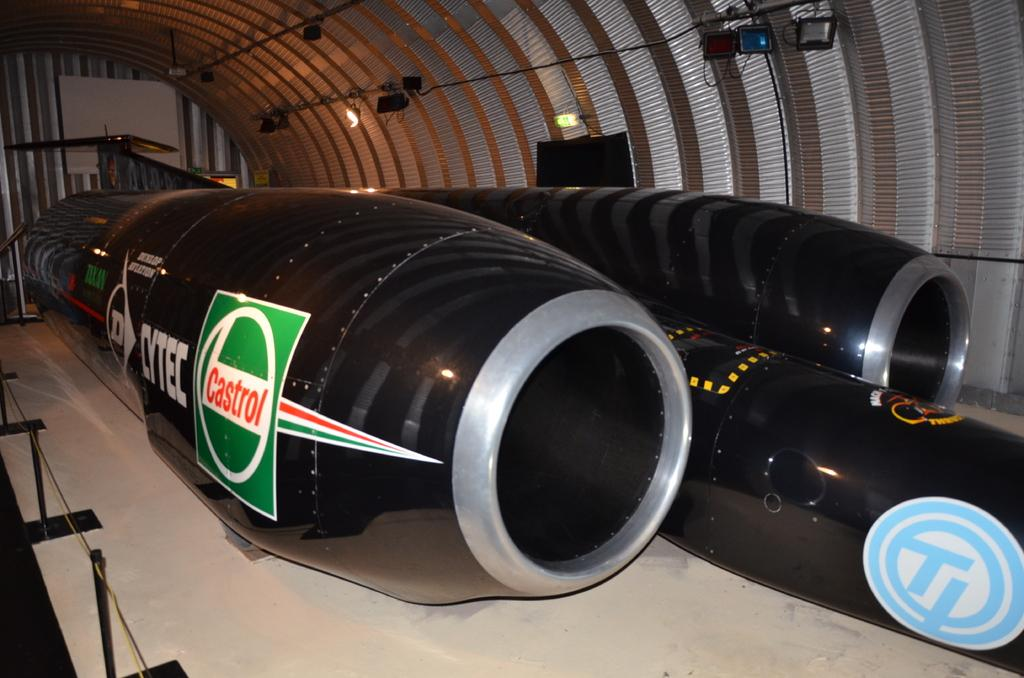Provide a one-sentence caption for the provided image. An airplane in a hanger sponsored by Castrol and Cytec. 